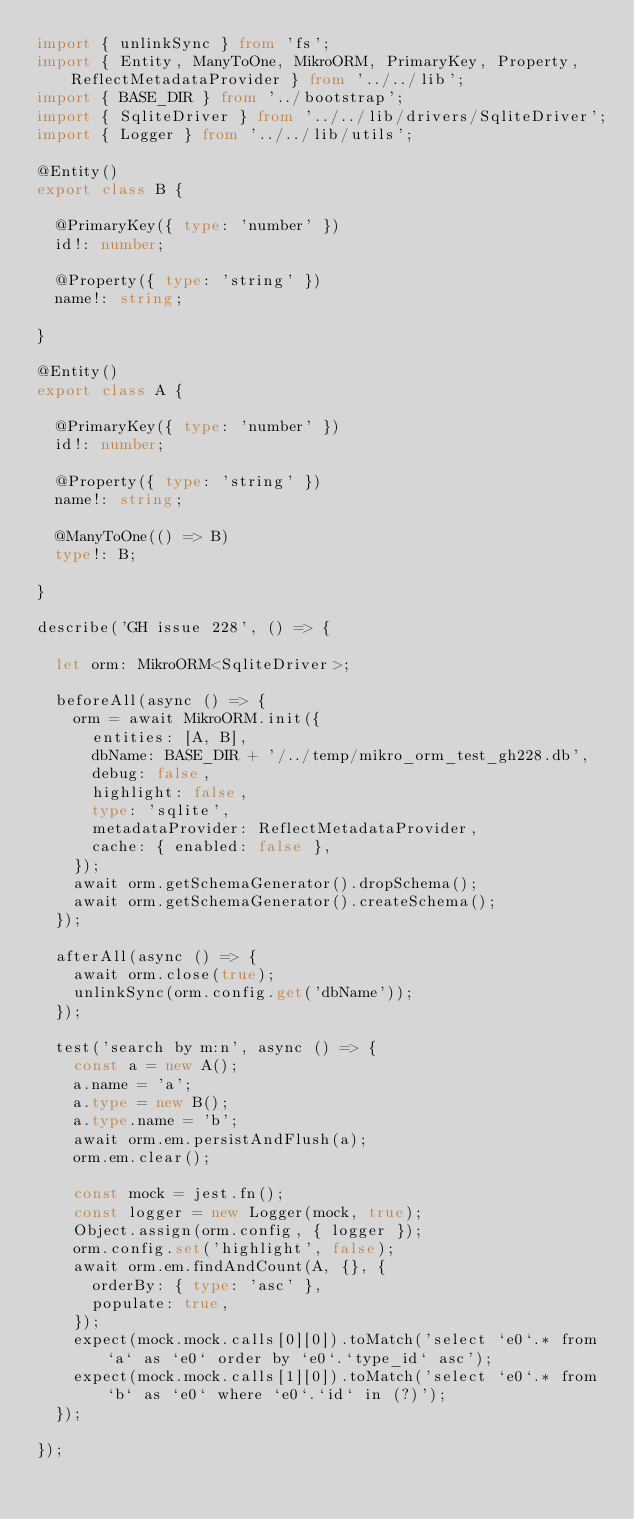Convert code to text. <code><loc_0><loc_0><loc_500><loc_500><_TypeScript_>import { unlinkSync } from 'fs';
import { Entity, ManyToOne, MikroORM, PrimaryKey, Property, ReflectMetadataProvider } from '../../lib';
import { BASE_DIR } from '../bootstrap';
import { SqliteDriver } from '../../lib/drivers/SqliteDriver';
import { Logger } from '../../lib/utils';

@Entity()
export class B {

  @PrimaryKey({ type: 'number' })
  id!: number;

  @Property({ type: 'string' })
  name!: string;

}

@Entity()
export class A {

  @PrimaryKey({ type: 'number' })
  id!: number;

  @Property({ type: 'string' })
  name!: string;

  @ManyToOne(() => B)
  type!: B;

}

describe('GH issue 228', () => {

  let orm: MikroORM<SqliteDriver>;

  beforeAll(async () => {
    orm = await MikroORM.init({
      entities: [A, B],
      dbName: BASE_DIR + '/../temp/mikro_orm_test_gh228.db',
      debug: false,
      highlight: false,
      type: 'sqlite',
      metadataProvider: ReflectMetadataProvider,
      cache: { enabled: false },
    });
    await orm.getSchemaGenerator().dropSchema();
    await orm.getSchemaGenerator().createSchema();
  });

  afterAll(async () => {
    await orm.close(true);
    unlinkSync(orm.config.get('dbName'));
  });

  test('search by m:n', async () => {
    const a = new A();
    a.name = 'a';
    a.type = new B();
    a.type.name = 'b';
    await orm.em.persistAndFlush(a);
    orm.em.clear();

    const mock = jest.fn();
    const logger = new Logger(mock, true);
    Object.assign(orm.config, { logger });
    orm.config.set('highlight', false);
    await orm.em.findAndCount(A, {}, {
      orderBy: { type: 'asc' },
      populate: true,
    });
    expect(mock.mock.calls[0][0]).toMatch('select `e0`.* from `a` as `e0` order by `e0`.`type_id` asc');
    expect(mock.mock.calls[1][0]).toMatch('select `e0`.* from `b` as `e0` where `e0`.`id` in (?)');
  });

});
</code> 